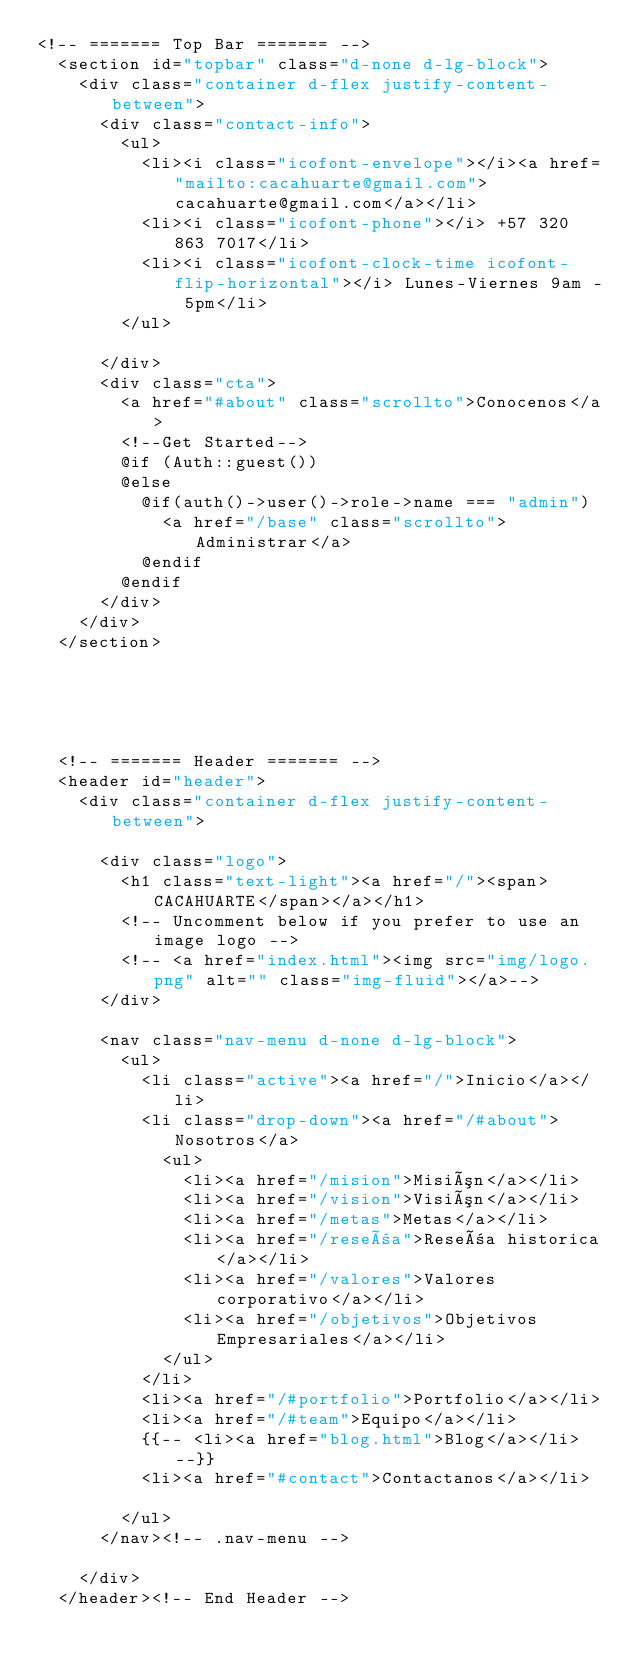Convert code to text. <code><loc_0><loc_0><loc_500><loc_500><_PHP_><!-- ======= Top Bar ======= -->
  <section id="topbar" class="d-none d-lg-block">
    <div class="container d-flex justify-content-between">
      <div class="contact-info">
        <ul>
          <li><i class="icofont-envelope"></i><a href="mailto:cacahuarte@gmail.com">cacahuarte@gmail.com</a></li>
          <li><i class="icofont-phone"></i> +57 320 863 7017</li>
          <li><i class="icofont-clock-time icofont-flip-horizontal"></i> Lunes-Viernes 9am - 5pm</li>
        </ul>

      </div>
      <div class="cta">
        <a href="#about" class="scrollto">Conocenos</a>
        <!--Get Started-->
        @if (Auth::guest())
        @else
          @if(auth()->user()->role->name === "admin")
            <a href="/base" class="scrollto">Administrar</a>
          @endif
        @endif
      </div>
    </div>
  </section>





  <!-- ======= Header ======= -->
  <header id="header">
    <div class="container d-flex justify-content-between">

      <div class="logo">
        <h1 class="text-light"><a href="/"><span>CACAHUARTE</span></a></h1>
        <!-- Uncomment below if you prefer to use an image logo -->
        <!-- <a href="index.html"><img src="img/logo.png" alt="" class="img-fluid"></a>-->
      </div>

      <nav class="nav-menu d-none d-lg-block">
        <ul>
          <li class="active"><a href="/">Inicio</a></li>
          <li class="drop-down"><a href="/#about">Nosotros</a>
            <ul>
              <li><a href="/mision">Misión</a></li>
              <li><a href="/vision">Visión</a></li>
              <li><a href="/metas">Metas</a></li>
              <li><a href="/reseña">Reseña historica</a></li>
              <li><a href="/valores">Valores corporativo</a></li>
              <li><a href="/objetivos">Objetivos Empresariales</a></li>
            </ul>
          </li>
          <li><a href="/#portfolio">Portfolio</a></li>
          <li><a href="/#team">Equipo</a></li>
          {{-- <li><a href="blog.html">Blog</a></li> --}}
          <li><a href="#contact">Contactanos</a></li>

        </ul>
      </nav><!-- .nav-menu -->

    </div>
  </header><!-- End Header --></code> 